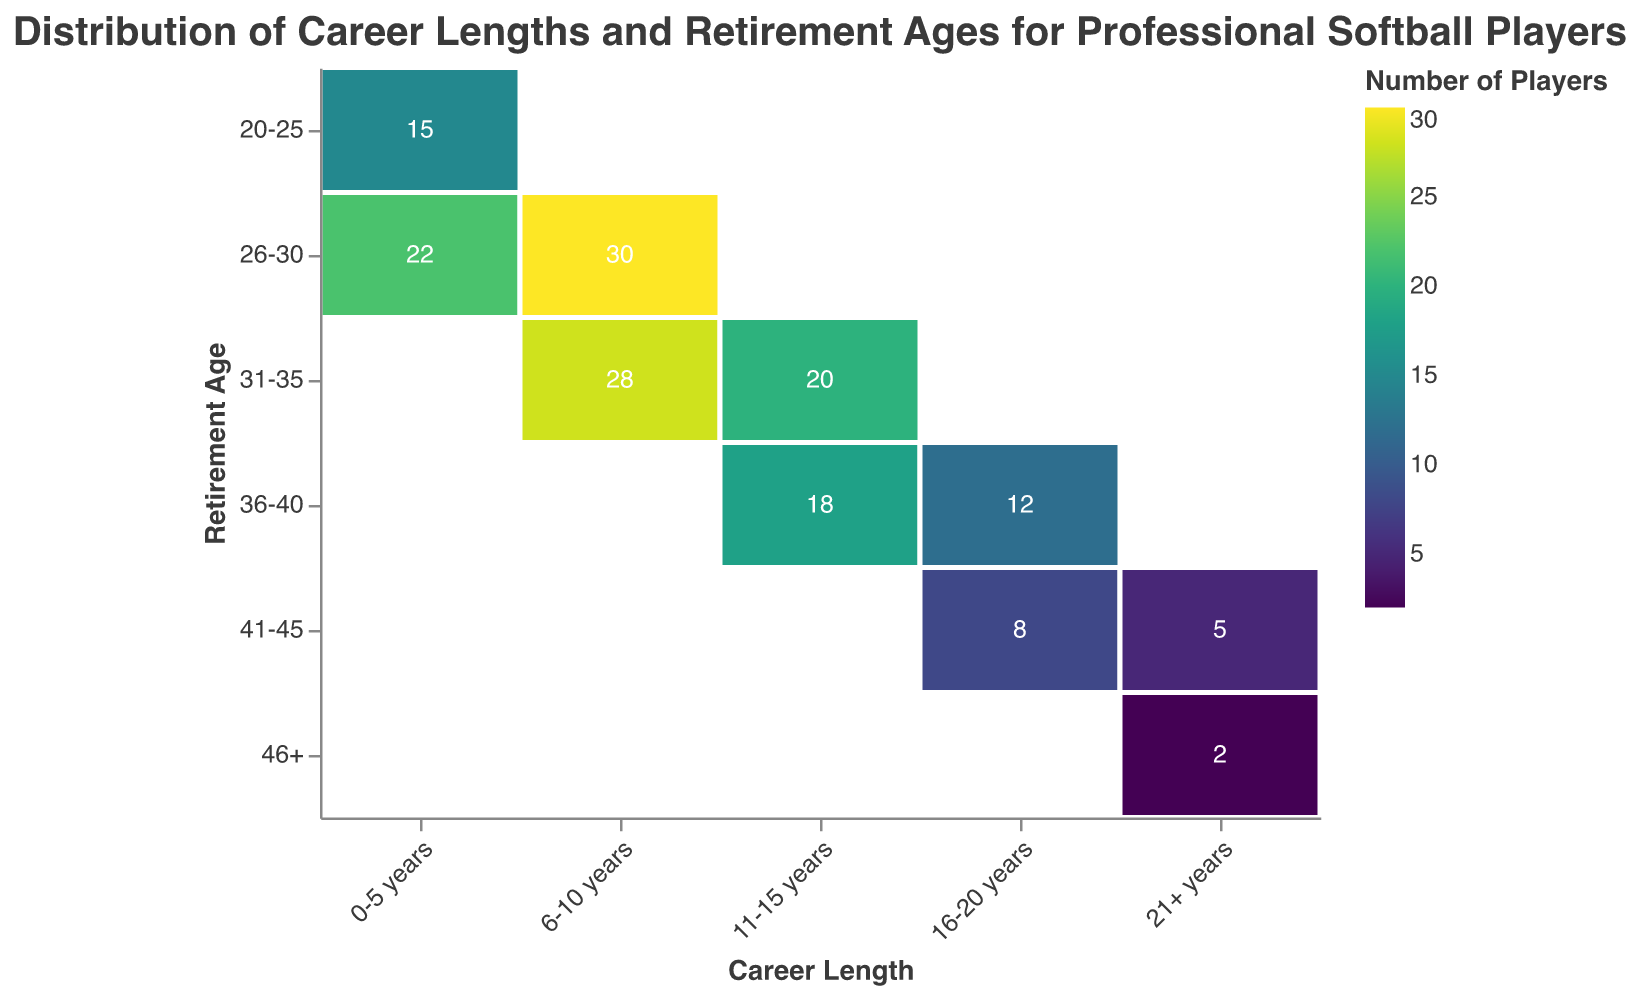What is the title of the plot? The title is located at the top of the plot and reads "Distribution of Career Lengths and Retirement Ages for Professional Softball Players".
Answer: Distribution of Career Lengths and Retirement Ages for Professional Softball Players How many players retired between the ages of 41-45? Looking at the values in the cells that intersect with the "41-45" retirement age row, we see two values: 8 and 5. Summing these values gives the total number of players, which is 8 + 5 = 13.
Answer: 13 Which career length category has the highest number of players retiring between the ages of 26-30? By examining the cells in the "26-30" retirement age row, the values for each career length category are 22 for "0-5 years" and 30 for "6-10 years". Comparing these, the highest value is 30, which corresponds to the "6-10 years" career length category.
Answer: 6-10 years What's the difference in the number of players retiring between the ages of 36-40 with career lengths of 11-15 years and 16-20 years? The number of players retiring between the ages of 36-40 with a career length of 11-15 years is 18. For career lengths of 16-20 years, it is 12. The difference is calculated as 18 - 12 = 6.
Answer: 6 Which retirement age category has the smallest number of players with a career length of 0-5 years? We look at the retirement ages in the row corresponding to "0-5 years". The values are 15 for "20-25" and 22 for "26-30". The smallest value is 15, located in the "20-25" category.
Answer: 20-25 How many players had a career length of more than 20 years? We examine the row corresponding to "21+ years". Summing up the values, we have 5 (for retirement age 41-45) + 2 (for retirement age 46+), which totals to 5 + 2 = 7.
Answer: 7 What is the most common retirement age range for players with career lengths of 11-15 years? Looking at the "11-15 years" career length row, the values for retirement ages are 20 for "31-35" and 18 for "36-40". The largest value is 20 for the "31-35" retirement age category.
Answer: 31-35 Which career length category has no players retiring at age 46+? We see that the only cell with a count in the "46+" column is for the "21+ years" indicating a count of 2. Thus, all other categories ("0-5 years", "6-10 years", "11-15 years", "16-20 years") have no players retiring at age 46+.
Answer: 0-5 years, 6-10 years, 11-15 years, 16-20 years 